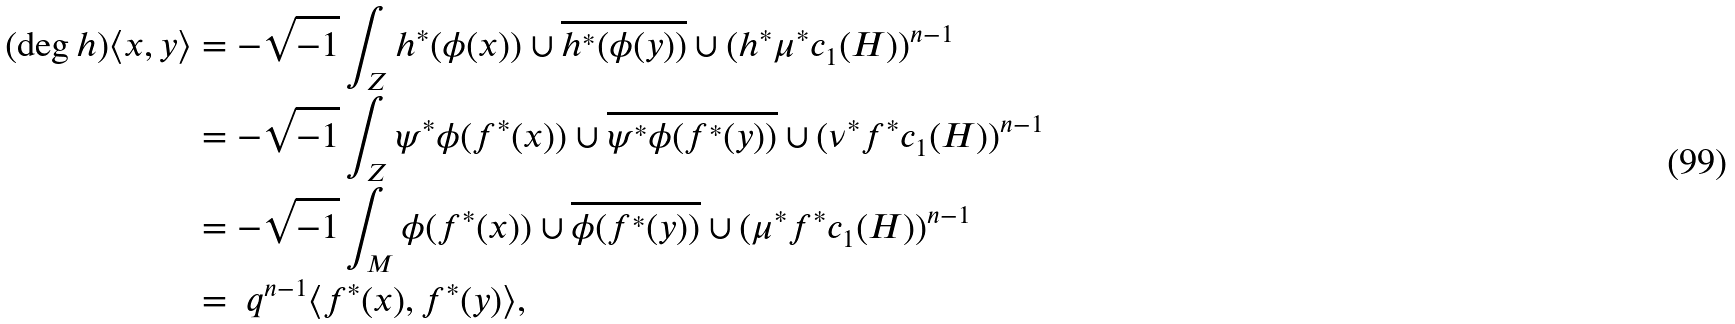<formula> <loc_0><loc_0><loc_500><loc_500>( \deg h ) \langle x , y \rangle & = - \sqrt { - 1 } \int _ { Z } h ^ { * } ( \phi ( x ) ) \cup \overline { h ^ { * } ( \phi ( y ) ) } \cup ( h ^ { * } \mu ^ { * } c _ { 1 } ( H ) ) ^ { n - 1 } \\ & = - \sqrt { - 1 } \int _ { Z } \psi ^ { * } \phi ( f ^ { * } ( x ) ) \cup \overline { \psi ^ { * } \phi ( f ^ { * } ( y ) ) } \cup ( \nu ^ { * } f ^ { * } c _ { 1 } ( H ) ) ^ { n - 1 } \\ & = - \sqrt { - 1 } \int _ { M } \phi ( f ^ { * } ( x ) ) \cup \overline { \phi ( f ^ { * } ( y ) ) } \cup ( \mu ^ { * } f ^ { * } c _ { 1 } ( H ) ) ^ { n - 1 } \\ & = \ q ^ { n - 1 } \langle f ^ { * } ( x ) , f ^ { * } ( y ) \rangle ,</formula> 